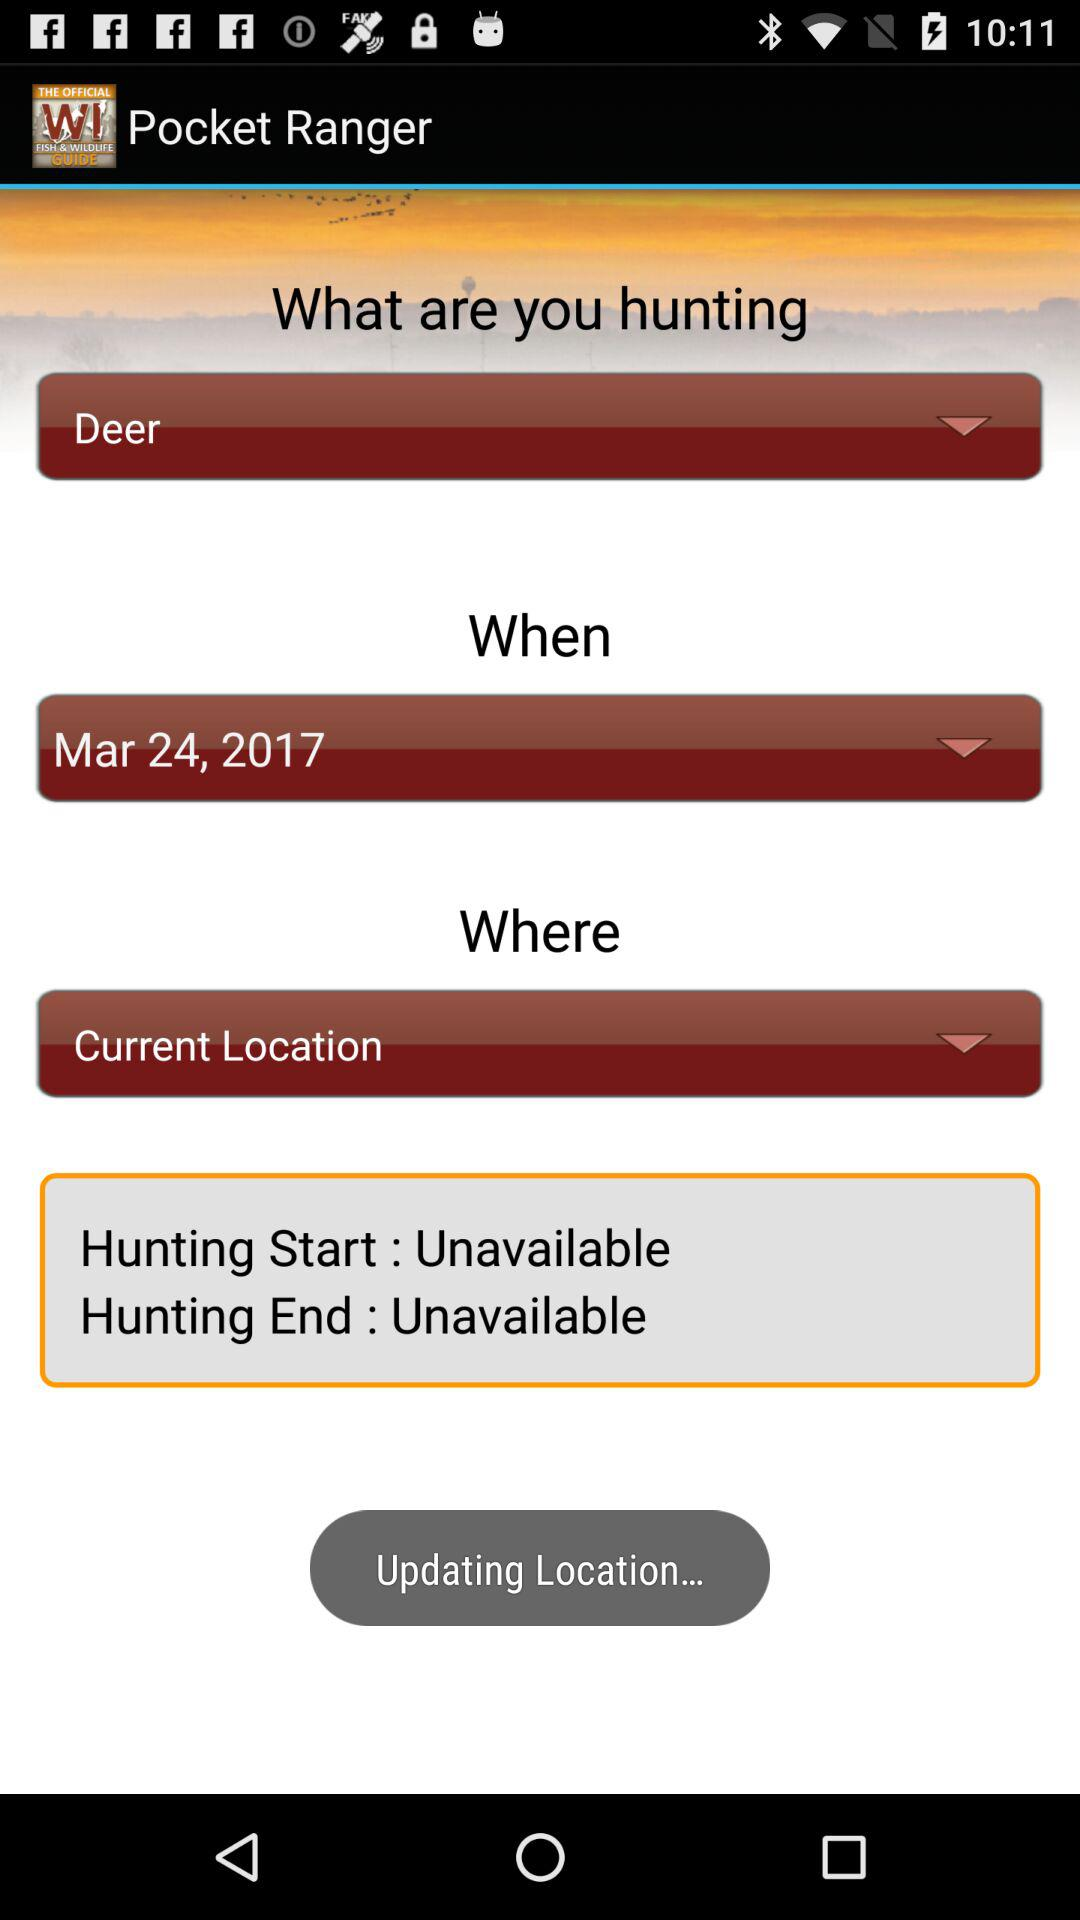What is the status of hunting start? The status is unavailable. 